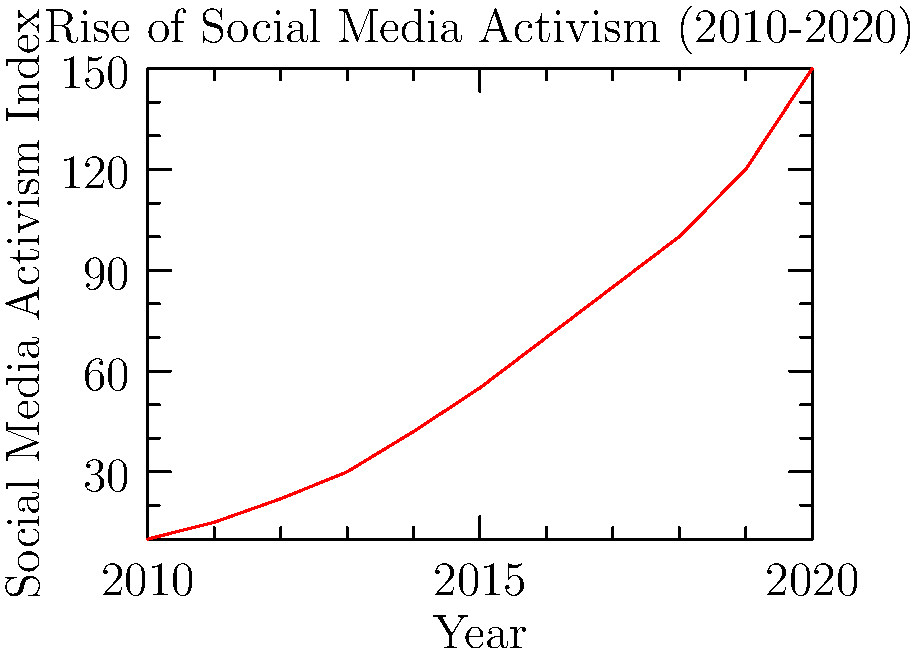Based on the line graph, what was the approximate percentage increase in social media activism from 2010 to 2020? To calculate the percentage increase in social media activism from 2010 to 2020:

1. Identify the values:
   - 2010 value: 10
   - 2020 value: 150

2. Calculate the difference:
   150 - 10 = 140

3. Divide the difference by the initial value:
   140 / 10 = 14

4. Multiply by 100 to get the percentage:
   14 * 100 = 1400%

The social media activism index increased by approximately 1400% from 2010 to 2020.
Answer: 1400% 